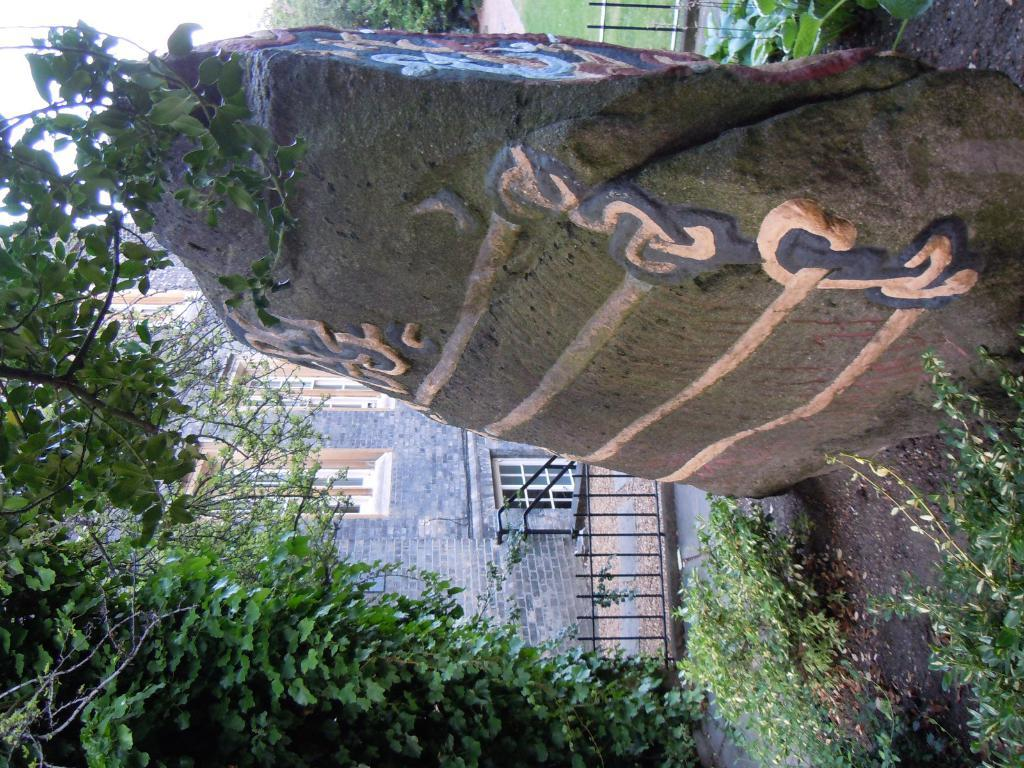What is located at the bottom of the image? There is a hill at the bottom of the image. What can be seen on the right side of the image? There are trees on the right side of the image. What is visible in the background of the image? There are buildings, trees, and a boundary in the background of the image. Can you tell me what instrument the monkey is playing in the image? There is no monkey or instrument present in the image. How does the brake work on the boundary in the image? There is no brake present in the image. 